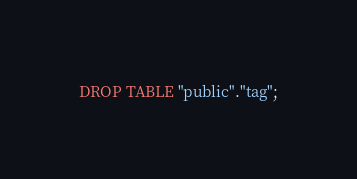Convert code to text. <code><loc_0><loc_0><loc_500><loc_500><_SQL_>DROP TABLE "public"."tag";
</code> 